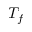<formula> <loc_0><loc_0><loc_500><loc_500>T _ { f }</formula> 